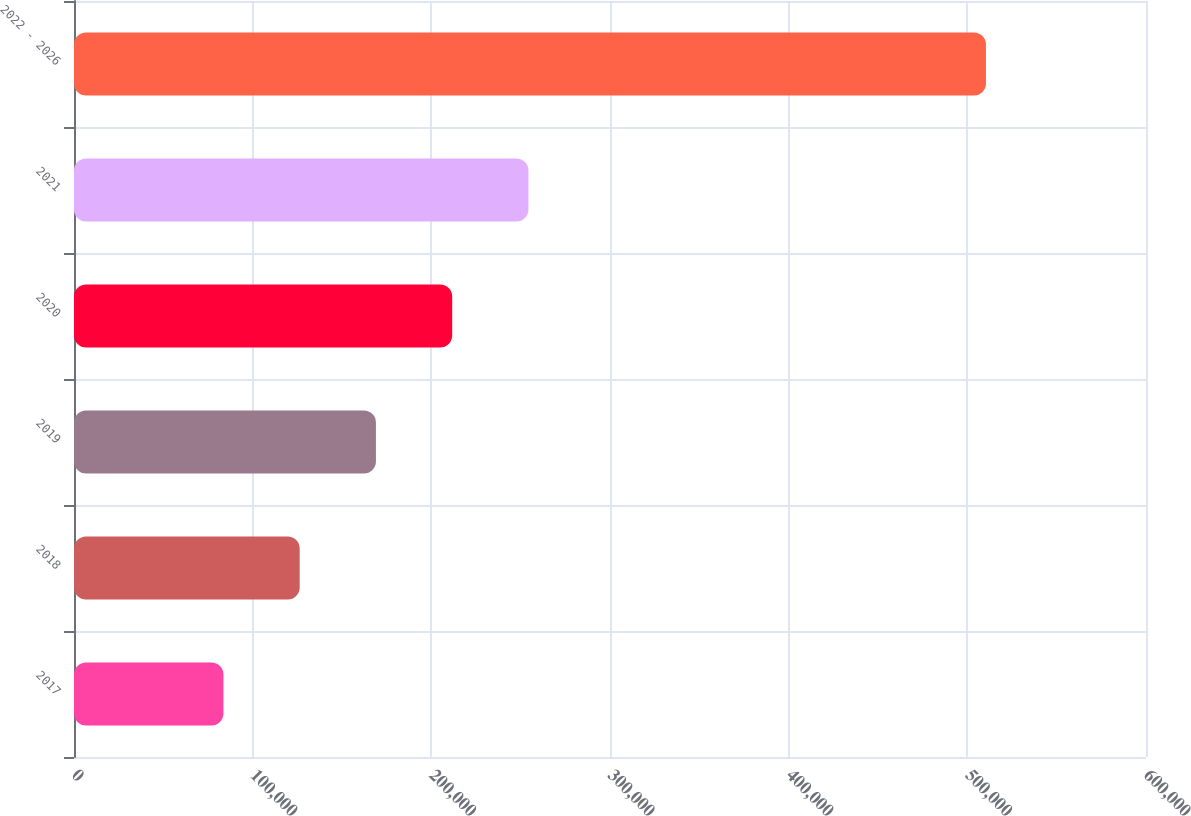Convert chart to OTSL. <chart><loc_0><loc_0><loc_500><loc_500><bar_chart><fcel>2017<fcel>2018<fcel>2019<fcel>2020<fcel>2021<fcel>2022 - 2026<nl><fcel>83638<fcel>126316<fcel>168994<fcel>211672<fcel>254350<fcel>510419<nl></chart> 